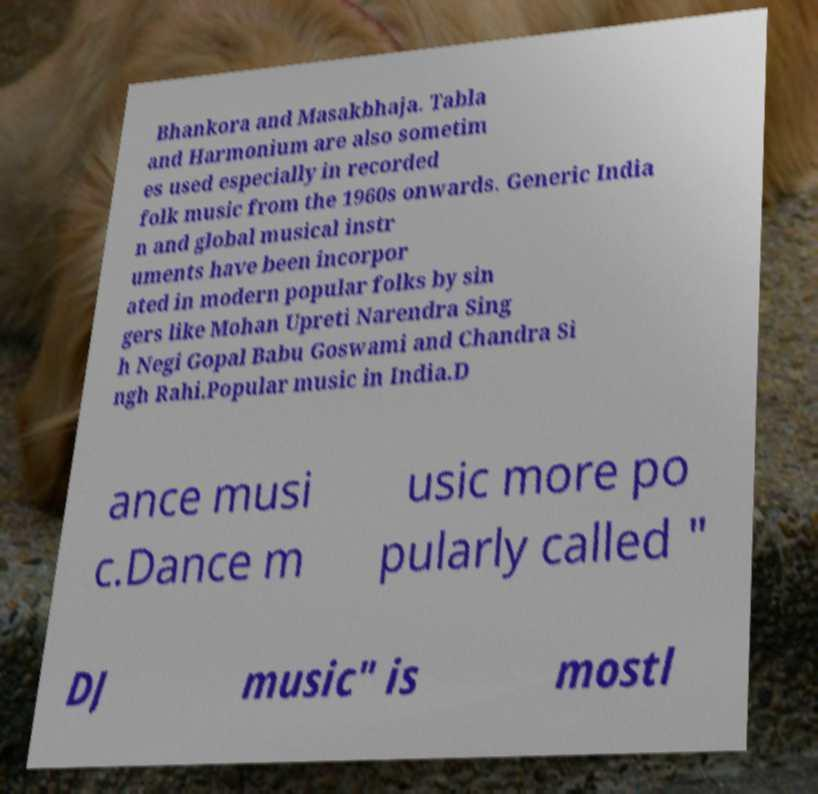Please read and relay the text visible in this image. What does it say? Bhankora and Masakbhaja. Tabla and Harmonium are also sometim es used especially in recorded folk music from the 1960s onwards. Generic India n and global musical instr uments have been incorpor ated in modern popular folks by sin gers like Mohan Upreti Narendra Sing h Negi Gopal Babu Goswami and Chandra Si ngh Rahi.Popular music in India.D ance musi c.Dance m usic more po pularly called " DJ music" is mostl 